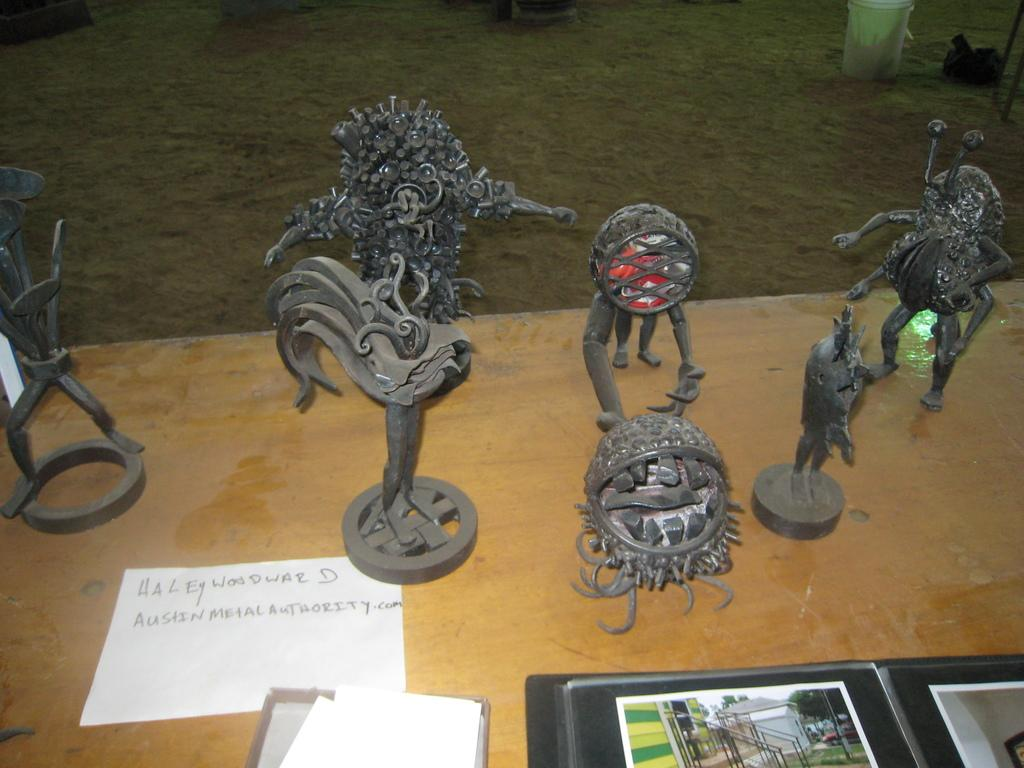What color are the statues in the image? The statues in the image are black. What else can be seen in the image besides the statues? Papers are present in the image. What is the color of the table in the image? The table in the image is brown. What can be found on the table? There are files on the brown color table. What type of objects are on the ground in the image? White and black color objects are on the ground in the image. What type of vegetable is being dropped on the ground in the image? There is no vegetable being dropped in the image; it only features statues, papers, files, and objects on the ground. What disease can be seen affecting the statues in the image? There is no disease affecting the statues in the image; they are simply black color statues. 